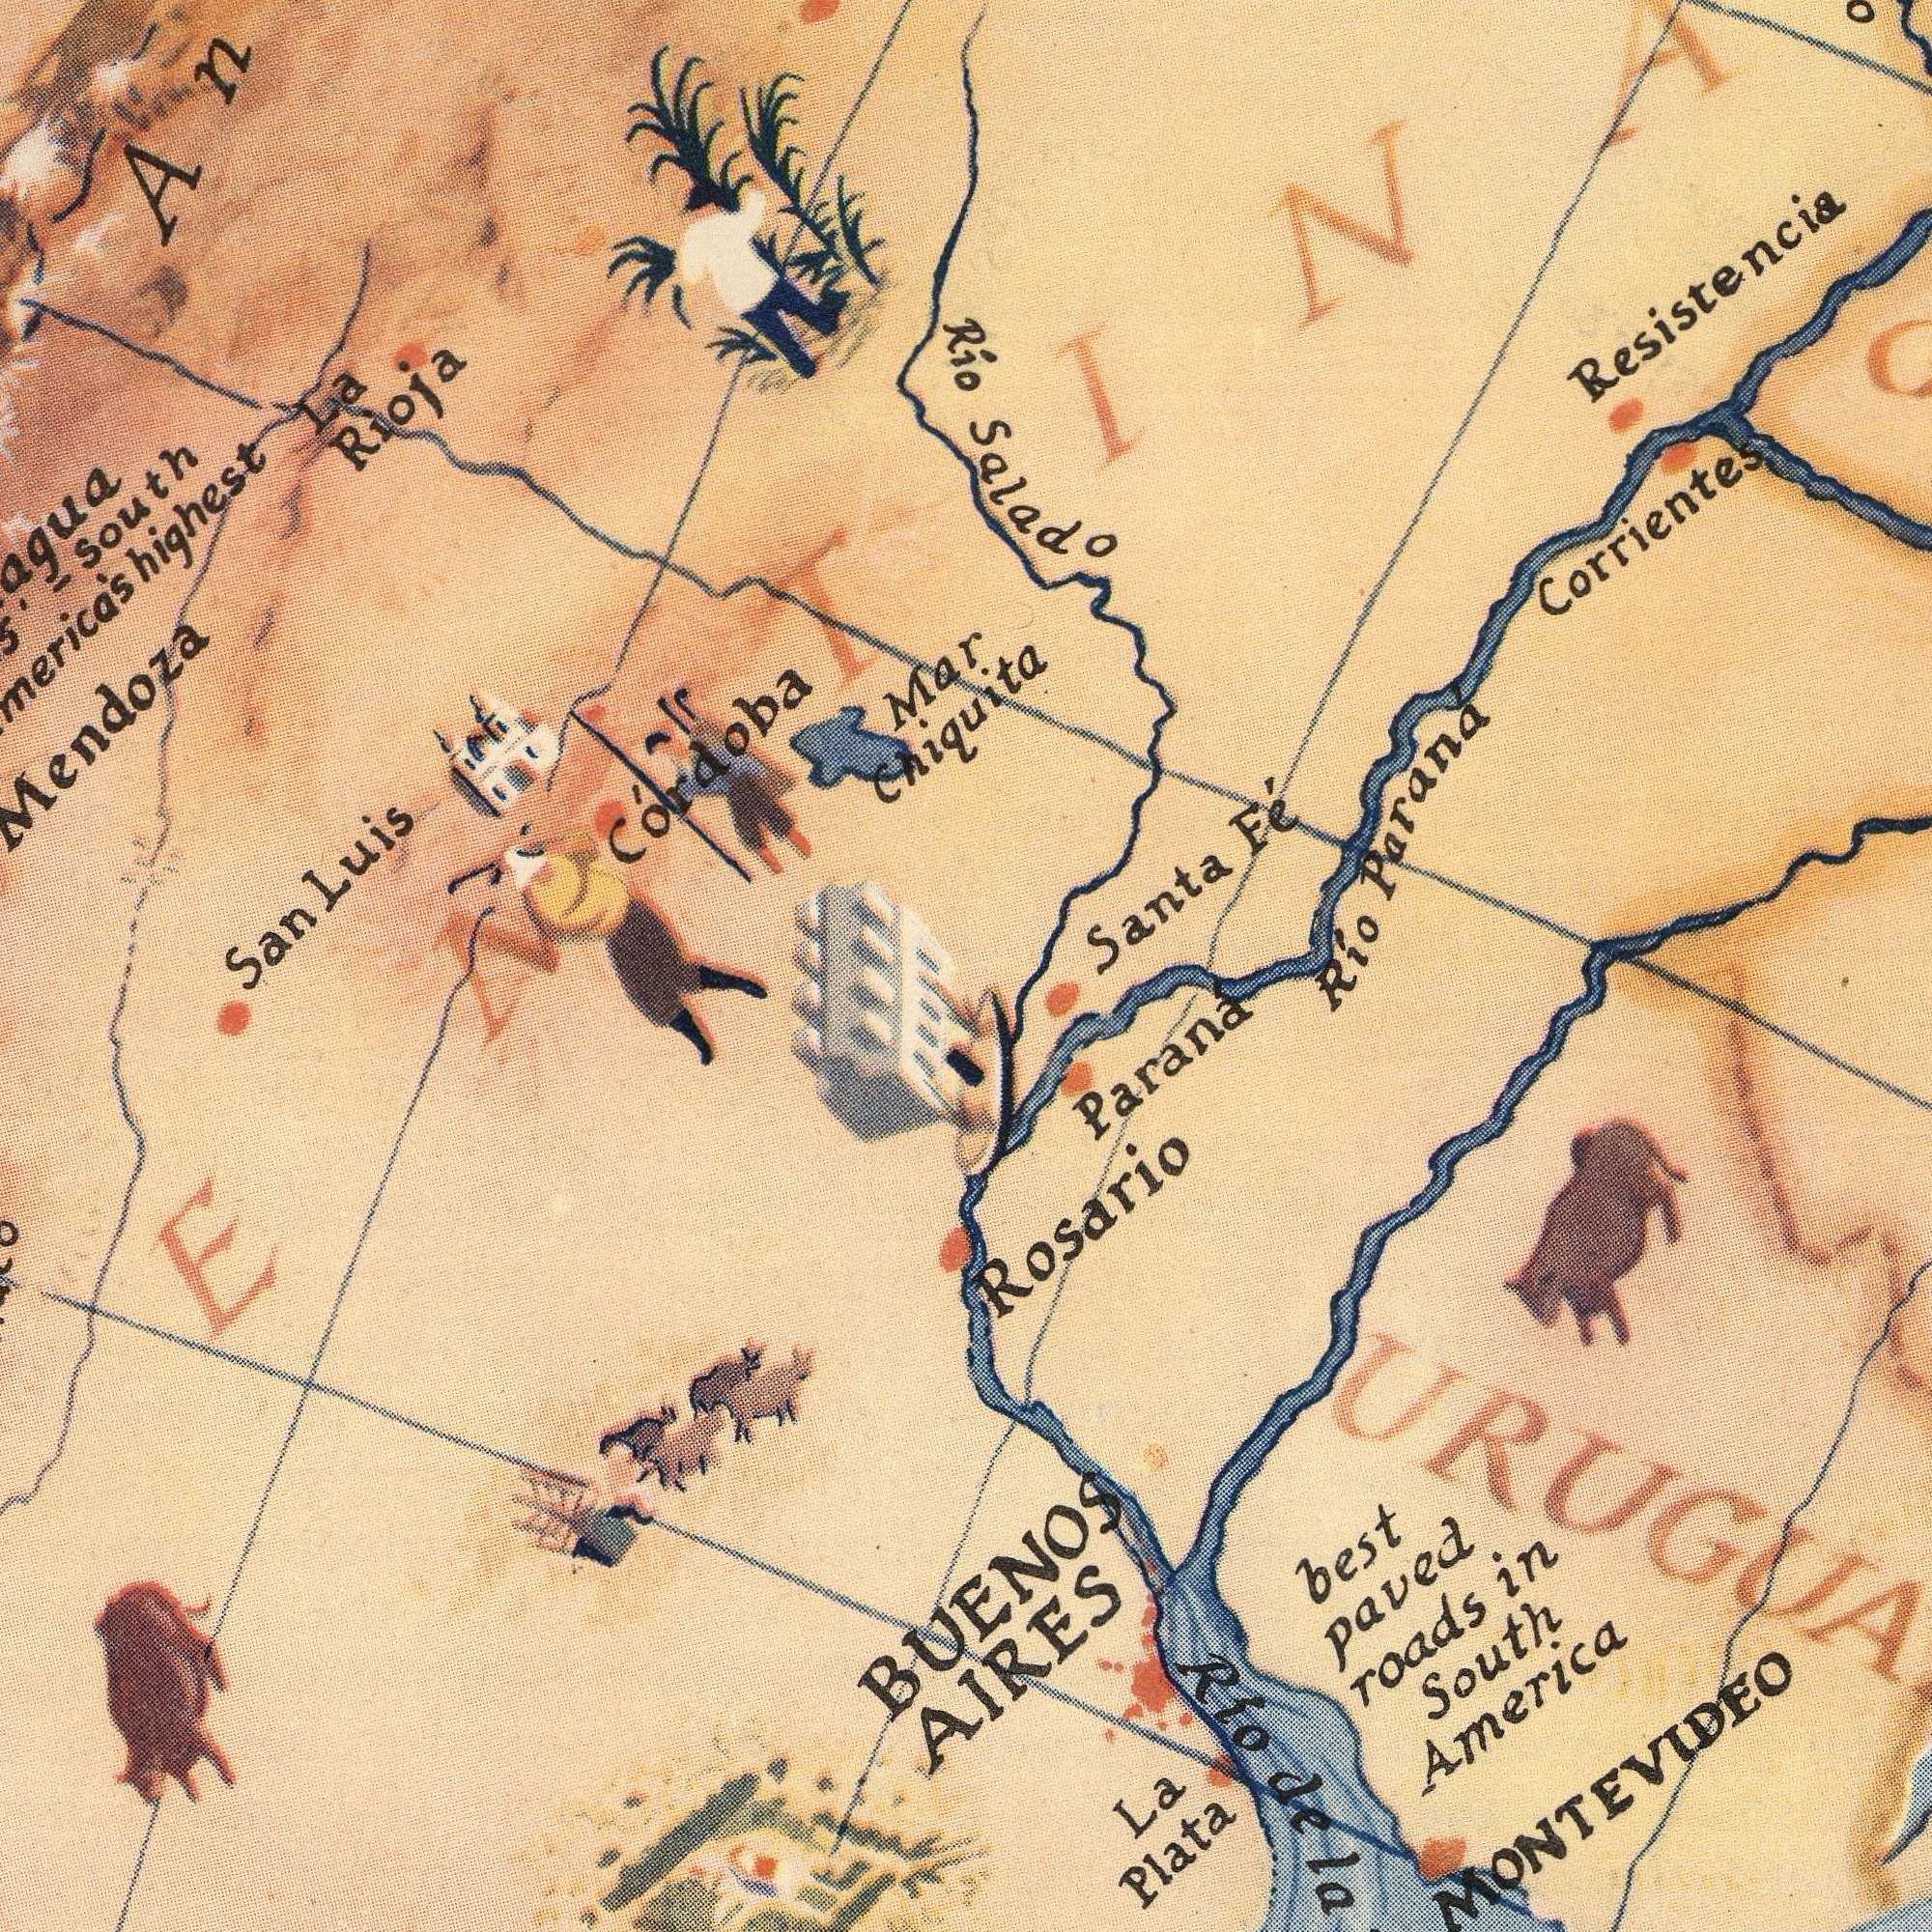What text is visible in the upper-right corner? Mar Chiquita Santa Fé Rio Parana Corrientes Resistencia Rio Salado What text can you see in the bottom-right section? best paved roads in South America La Plata Rosario Parana Rio dela dela MONTEVIDEO BUENOS AIRES What text can you see in the top-left section? La Rioja San Luis Mendoza Córdoba -south highest 